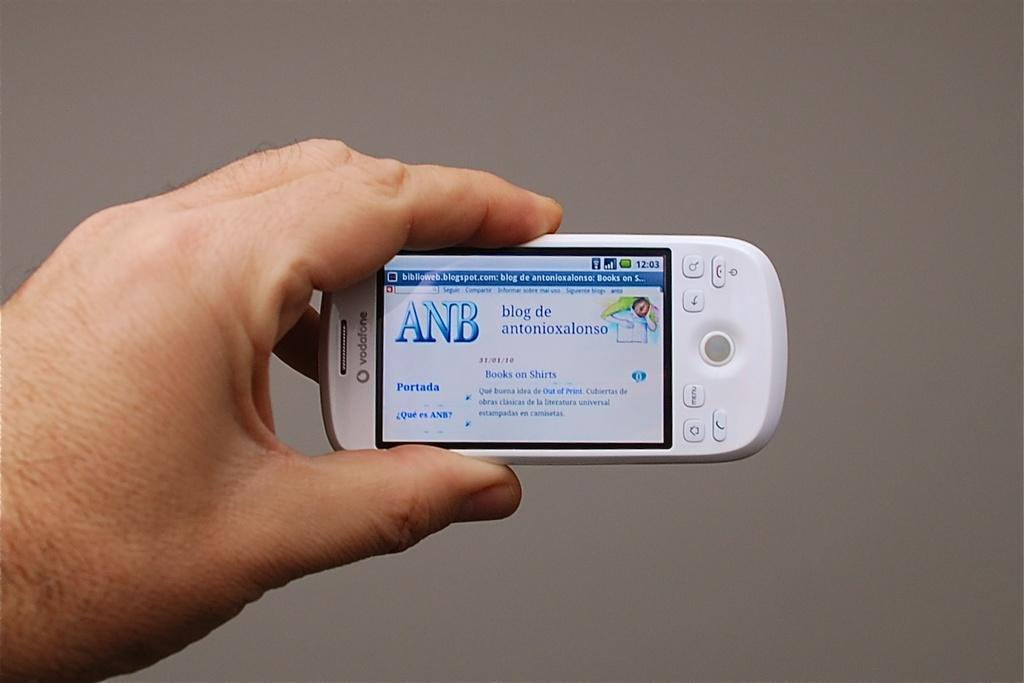<image>
Summarize the visual content of the image. A hand holding a small cell phone that has a screen pulled up that says ANB blog de antonioxalonso on it. 